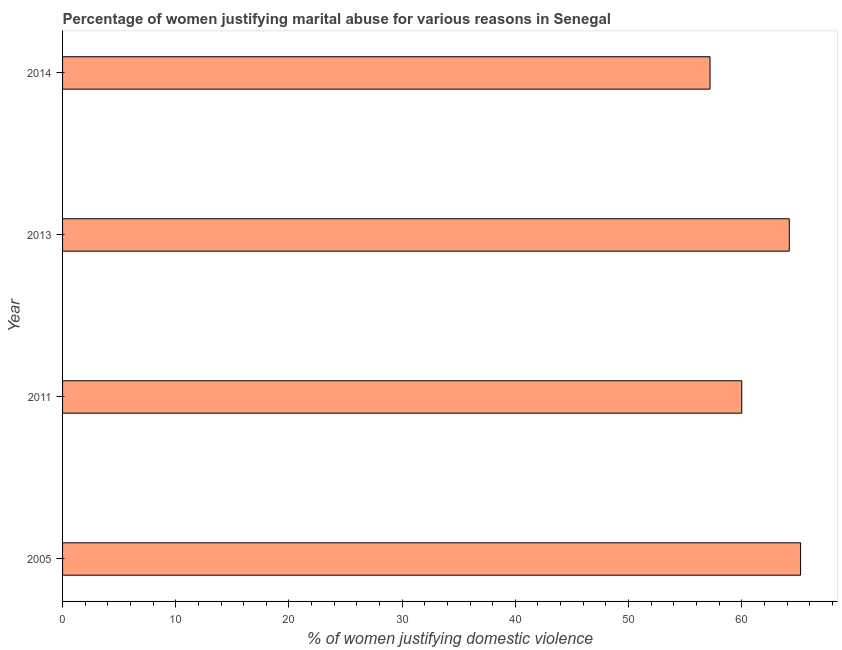Does the graph contain any zero values?
Keep it short and to the point. No. Does the graph contain grids?
Keep it short and to the point. No. What is the title of the graph?
Give a very brief answer. Percentage of women justifying marital abuse for various reasons in Senegal. What is the label or title of the X-axis?
Your response must be concise. % of women justifying domestic violence. What is the label or title of the Y-axis?
Ensure brevity in your answer.  Year. What is the percentage of women justifying marital abuse in 2014?
Provide a short and direct response. 57.2. Across all years, what is the maximum percentage of women justifying marital abuse?
Keep it short and to the point. 65.2. Across all years, what is the minimum percentage of women justifying marital abuse?
Offer a very short reply. 57.2. What is the sum of the percentage of women justifying marital abuse?
Keep it short and to the point. 246.6. What is the difference between the percentage of women justifying marital abuse in 2005 and 2014?
Give a very brief answer. 8. What is the average percentage of women justifying marital abuse per year?
Offer a terse response. 61.65. What is the median percentage of women justifying marital abuse?
Provide a succinct answer. 62.1. What is the ratio of the percentage of women justifying marital abuse in 2011 to that in 2014?
Offer a terse response. 1.05. Is the difference between the percentage of women justifying marital abuse in 2011 and 2013 greater than the difference between any two years?
Your answer should be compact. No. What is the difference between the highest and the second highest percentage of women justifying marital abuse?
Offer a terse response. 1. What is the difference between the highest and the lowest percentage of women justifying marital abuse?
Keep it short and to the point. 8. In how many years, is the percentage of women justifying marital abuse greater than the average percentage of women justifying marital abuse taken over all years?
Keep it short and to the point. 2. What is the difference between two consecutive major ticks on the X-axis?
Offer a very short reply. 10. Are the values on the major ticks of X-axis written in scientific E-notation?
Ensure brevity in your answer.  No. What is the % of women justifying domestic violence in 2005?
Offer a very short reply. 65.2. What is the % of women justifying domestic violence of 2013?
Your answer should be very brief. 64.2. What is the % of women justifying domestic violence of 2014?
Your answer should be very brief. 57.2. What is the difference between the % of women justifying domestic violence in 2005 and 2011?
Ensure brevity in your answer.  5.2. What is the difference between the % of women justifying domestic violence in 2005 and 2013?
Your response must be concise. 1. What is the difference between the % of women justifying domestic violence in 2005 and 2014?
Offer a terse response. 8. What is the difference between the % of women justifying domestic violence in 2011 and 2013?
Offer a terse response. -4.2. What is the difference between the % of women justifying domestic violence in 2011 and 2014?
Keep it short and to the point. 2.8. What is the ratio of the % of women justifying domestic violence in 2005 to that in 2011?
Provide a succinct answer. 1.09. What is the ratio of the % of women justifying domestic violence in 2005 to that in 2014?
Provide a short and direct response. 1.14. What is the ratio of the % of women justifying domestic violence in 2011 to that in 2013?
Offer a terse response. 0.94. What is the ratio of the % of women justifying domestic violence in 2011 to that in 2014?
Give a very brief answer. 1.05. What is the ratio of the % of women justifying domestic violence in 2013 to that in 2014?
Your response must be concise. 1.12. 